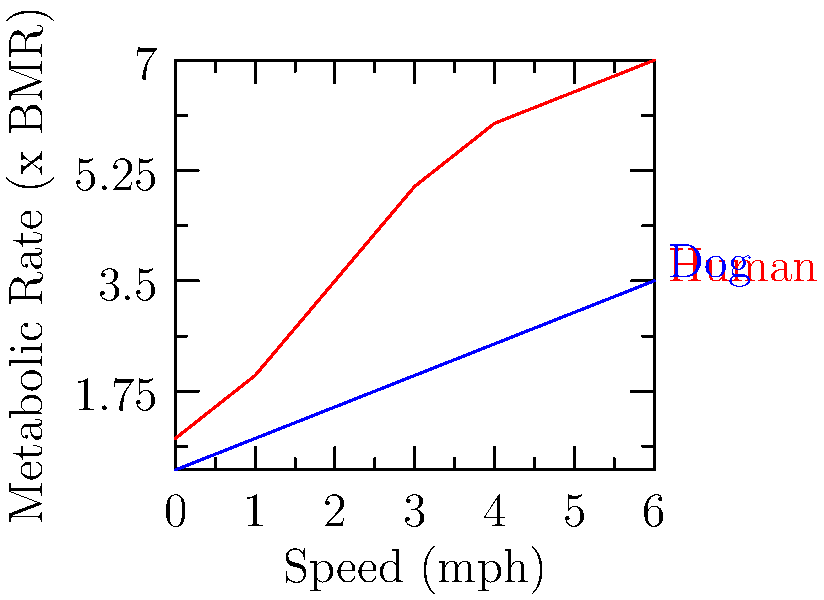Based on the graph showing the metabolic rates for humans and dogs at different walking speeds, estimate the total calories burned by both the dog walker and their Labrador during a 30-minute walk at 3 mph. Assume the dog walker weighs 70 kg and the Labrador weighs 30 kg. (Note: 1 BMR ≈ 1 kcal/kg/hour) To solve this problem, we'll follow these steps:

1. Determine the metabolic rates at 3 mph from the graph:
   Human: 5x BMR
   Dog: 2x BMR

2. Calculate the base metabolic rate (BMR) for each:
   Human BMR = 70 kg × 1 kcal/kg/hour = 70 kcal/hour
   Dog BMR = 30 kg × 1 kcal/kg/hour = 30 kcal/hour

3. Calculate the metabolic rate at 3 mph:
   Human: 5 × 70 kcal/hour = 350 kcal/hour
   Dog: 2 × 30 kcal/hour = 60 kcal/hour

4. Convert the 30-minute walk to hours:
   30 minutes = 0.5 hours

5. Calculate calories burned during the walk:
   Human: 350 kcal/hour × 0.5 hours = 175 kcal
   Dog: 60 kcal/hour × 0.5 hours = 30 kcal

6. Sum the total calories burned:
   Total = Human + Dog = 175 kcal + 30 kcal = 205 kcal
Answer: 205 kcal 